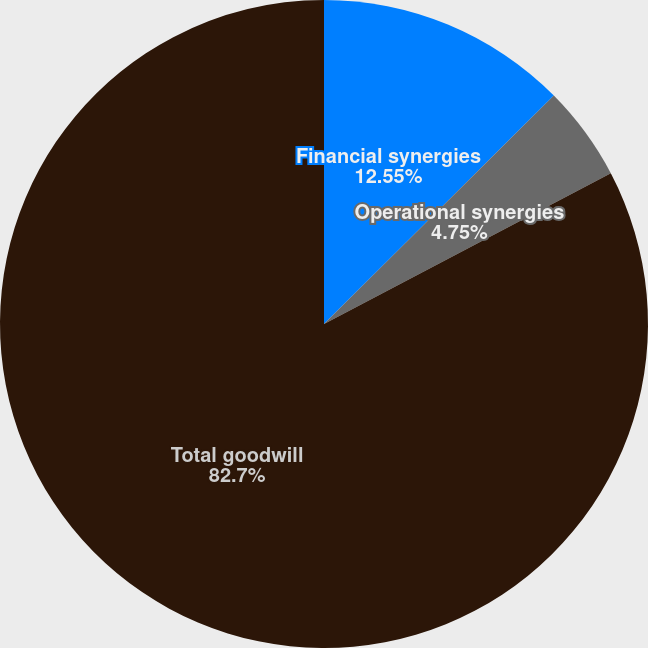Convert chart. <chart><loc_0><loc_0><loc_500><loc_500><pie_chart><fcel>Financial synergies<fcel>Operational synergies<fcel>Total goodwill<nl><fcel>12.55%<fcel>4.75%<fcel>82.7%<nl></chart> 